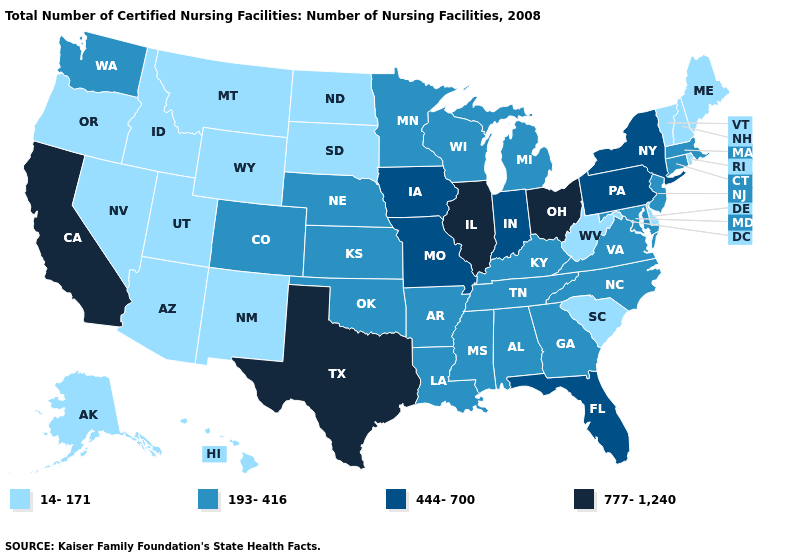Name the states that have a value in the range 444-700?
Give a very brief answer. Florida, Indiana, Iowa, Missouri, New York, Pennsylvania. What is the value of California?
Short answer required. 777-1,240. Which states have the highest value in the USA?
Short answer required. California, Illinois, Ohio, Texas. What is the value of West Virginia?
Quick response, please. 14-171. Name the states that have a value in the range 777-1,240?
Short answer required. California, Illinois, Ohio, Texas. Does Minnesota have the lowest value in the USA?
Give a very brief answer. No. What is the value of Pennsylvania?
Quick response, please. 444-700. Does Iowa have the same value as Florida?
Quick response, please. Yes. Is the legend a continuous bar?
Answer briefly. No. Name the states that have a value in the range 193-416?
Answer briefly. Alabama, Arkansas, Colorado, Connecticut, Georgia, Kansas, Kentucky, Louisiana, Maryland, Massachusetts, Michigan, Minnesota, Mississippi, Nebraska, New Jersey, North Carolina, Oklahoma, Tennessee, Virginia, Washington, Wisconsin. Name the states that have a value in the range 14-171?
Write a very short answer. Alaska, Arizona, Delaware, Hawaii, Idaho, Maine, Montana, Nevada, New Hampshire, New Mexico, North Dakota, Oregon, Rhode Island, South Carolina, South Dakota, Utah, Vermont, West Virginia, Wyoming. Does Vermont have the highest value in the Northeast?
Answer briefly. No. Does New Jersey have the highest value in the USA?
Write a very short answer. No. Among the states that border Massachusetts , which have the highest value?
Keep it brief. New York. Which states hav the highest value in the West?
Write a very short answer. California. 